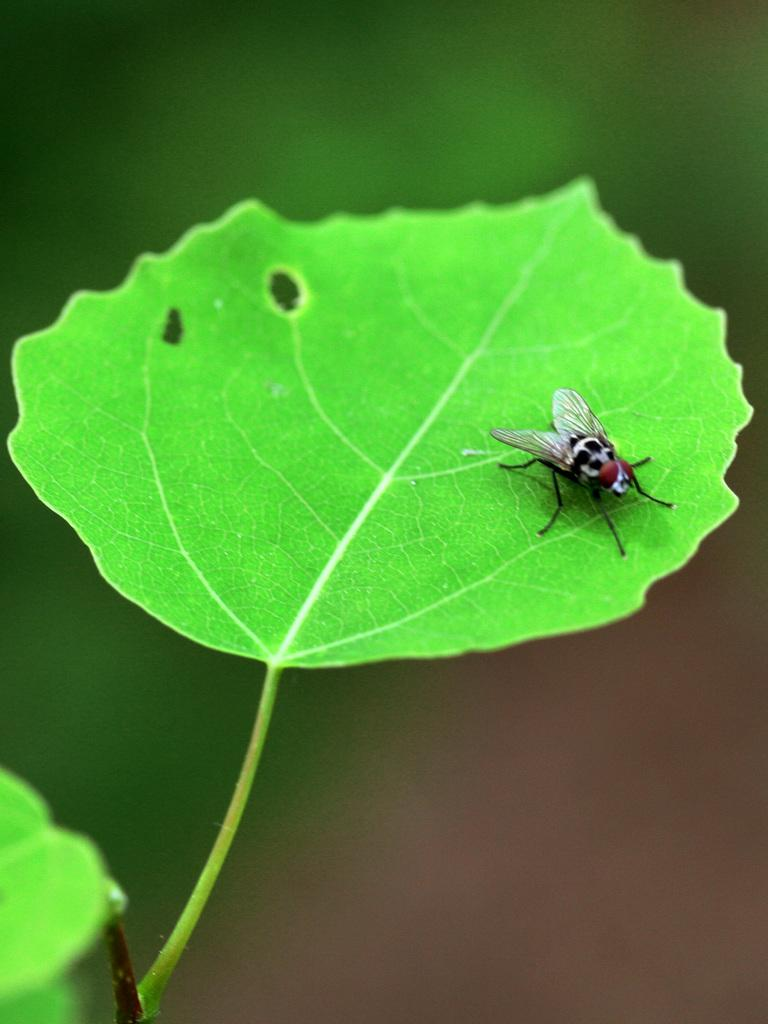What type of plant material is present in the image? There is a green leaf in the image. What is located on the leaf in the image? There is an insect on the leaf. Can you describe the background of the image? The background of the image is blurred. What is the price of the cows grazing in the background of the image? There are no cows present in the image, and therefore no price can be determined. How many birds can be seen flying in the image? There are no birds visible in the image. 